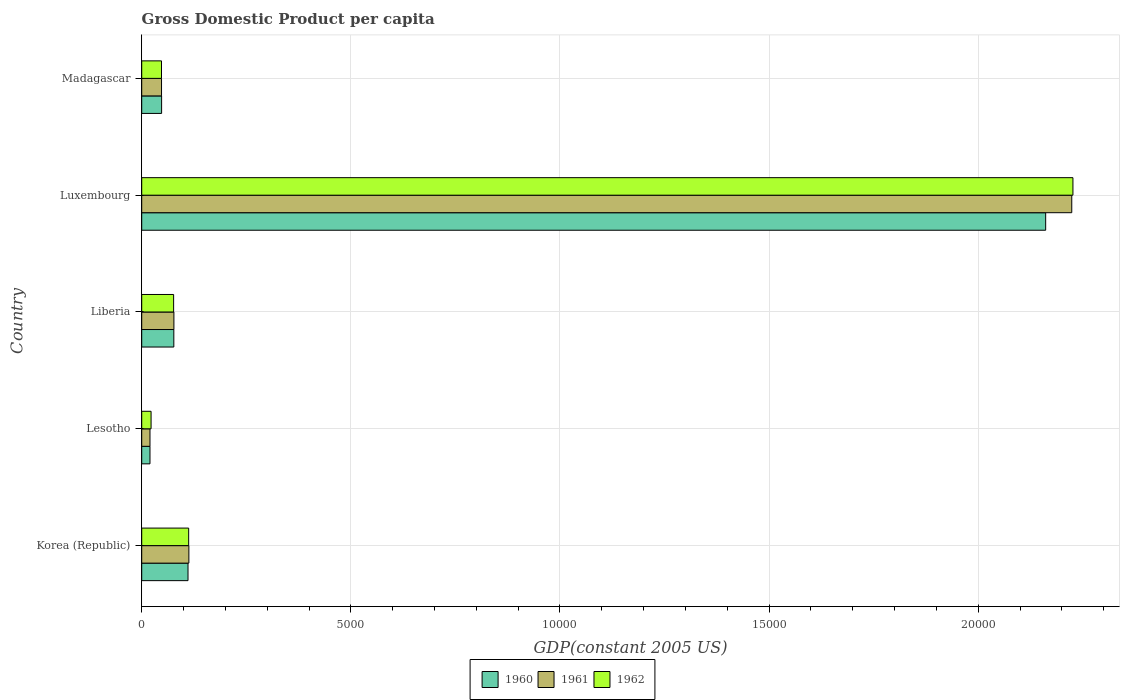How many groups of bars are there?
Give a very brief answer. 5. Are the number of bars on each tick of the Y-axis equal?
Your response must be concise. Yes. What is the label of the 3rd group of bars from the top?
Your answer should be compact. Liberia. What is the GDP per capita in 1962 in Luxembourg?
Provide a succinct answer. 2.23e+04. Across all countries, what is the maximum GDP per capita in 1960?
Make the answer very short. 2.16e+04. Across all countries, what is the minimum GDP per capita in 1961?
Provide a succinct answer. 197.61. In which country was the GDP per capita in 1961 maximum?
Keep it short and to the point. Luxembourg. In which country was the GDP per capita in 1960 minimum?
Your answer should be very brief. Lesotho. What is the total GDP per capita in 1962 in the graph?
Provide a short and direct response. 2.48e+04. What is the difference between the GDP per capita in 1960 in Korea (Republic) and that in Madagascar?
Your response must be concise. 631.26. What is the difference between the GDP per capita in 1960 in Luxembourg and the GDP per capita in 1962 in Madagascar?
Make the answer very short. 2.11e+04. What is the average GDP per capita in 1960 per country?
Provide a short and direct response. 4832.16. What is the difference between the GDP per capita in 1960 and GDP per capita in 1961 in Luxembourg?
Offer a very short reply. -624.17. What is the ratio of the GDP per capita in 1960 in Lesotho to that in Luxembourg?
Your response must be concise. 0.01. Is the GDP per capita in 1962 in Korea (Republic) less than that in Madagascar?
Provide a succinct answer. No. Is the difference between the GDP per capita in 1960 in Korea (Republic) and Lesotho greater than the difference between the GDP per capita in 1961 in Korea (Republic) and Lesotho?
Give a very brief answer. No. What is the difference between the highest and the second highest GDP per capita in 1960?
Give a very brief answer. 2.05e+04. What is the difference between the highest and the lowest GDP per capita in 1960?
Provide a succinct answer. 2.14e+04. What does the 2nd bar from the bottom in Korea (Republic) represents?
Give a very brief answer. 1961. Does the graph contain grids?
Provide a short and direct response. Yes. What is the title of the graph?
Offer a terse response. Gross Domestic Product per capita. Does "2013" appear as one of the legend labels in the graph?
Offer a terse response. No. What is the label or title of the X-axis?
Provide a succinct answer. GDP(constant 2005 US). What is the label or title of the Y-axis?
Your response must be concise. Country. What is the GDP(constant 2005 US) of 1960 in Korea (Republic)?
Your answer should be compact. 1106.76. What is the GDP(constant 2005 US) in 1961 in Korea (Republic)?
Your response must be concise. 1127.44. What is the GDP(constant 2005 US) of 1962 in Korea (Republic)?
Provide a succinct answer. 1122.59. What is the GDP(constant 2005 US) in 1960 in Lesotho?
Make the answer very short. 197.38. What is the GDP(constant 2005 US) in 1961 in Lesotho?
Provide a succinct answer. 197.61. What is the GDP(constant 2005 US) in 1962 in Lesotho?
Keep it short and to the point. 223.86. What is the GDP(constant 2005 US) of 1960 in Liberia?
Keep it short and to the point. 767.6. What is the GDP(constant 2005 US) of 1961 in Liberia?
Offer a terse response. 769.44. What is the GDP(constant 2005 US) of 1962 in Liberia?
Give a very brief answer. 762.88. What is the GDP(constant 2005 US) of 1960 in Luxembourg?
Your answer should be very brief. 2.16e+04. What is the GDP(constant 2005 US) of 1961 in Luxembourg?
Make the answer very short. 2.22e+04. What is the GDP(constant 2005 US) in 1962 in Luxembourg?
Give a very brief answer. 2.23e+04. What is the GDP(constant 2005 US) in 1960 in Madagascar?
Offer a very short reply. 475.5. What is the GDP(constant 2005 US) in 1961 in Madagascar?
Keep it short and to the point. 473.7. What is the GDP(constant 2005 US) in 1962 in Madagascar?
Ensure brevity in your answer.  472.78. Across all countries, what is the maximum GDP(constant 2005 US) in 1960?
Offer a terse response. 2.16e+04. Across all countries, what is the maximum GDP(constant 2005 US) of 1961?
Give a very brief answer. 2.22e+04. Across all countries, what is the maximum GDP(constant 2005 US) of 1962?
Your response must be concise. 2.23e+04. Across all countries, what is the minimum GDP(constant 2005 US) of 1960?
Offer a very short reply. 197.38. Across all countries, what is the minimum GDP(constant 2005 US) of 1961?
Keep it short and to the point. 197.61. Across all countries, what is the minimum GDP(constant 2005 US) of 1962?
Provide a short and direct response. 223.86. What is the total GDP(constant 2005 US) of 1960 in the graph?
Keep it short and to the point. 2.42e+04. What is the total GDP(constant 2005 US) in 1961 in the graph?
Keep it short and to the point. 2.48e+04. What is the total GDP(constant 2005 US) of 1962 in the graph?
Ensure brevity in your answer.  2.48e+04. What is the difference between the GDP(constant 2005 US) in 1960 in Korea (Republic) and that in Lesotho?
Provide a succinct answer. 909.38. What is the difference between the GDP(constant 2005 US) of 1961 in Korea (Republic) and that in Lesotho?
Provide a short and direct response. 929.82. What is the difference between the GDP(constant 2005 US) in 1962 in Korea (Republic) and that in Lesotho?
Offer a very short reply. 898.73. What is the difference between the GDP(constant 2005 US) of 1960 in Korea (Republic) and that in Liberia?
Offer a very short reply. 339.16. What is the difference between the GDP(constant 2005 US) in 1961 in Korea (Republic) and that in Liberia?
Provide a succinct answer. 357.99. What is the difference between the GDP(constant 2005 US) of 1962 in Korea (Republic) and that in Liberia?
Make the answer very short. 359.71. What is the difference between the GDP(constant 2005 US) of 1960 in Korea (Republic) and that in Luxembourg?
Keep it short and to the point. -2.05e+04. What is the difference between the GDP(constant 2005 US) in 1961 in Korea (Republic) and that in Luxembourg?
Keep it short and to the point. -2.11e+04. What is the difference between the GDP(constant 2005 US) of 1962 in Korea (Republic) and that in Luxembourg?
Make the answer very short. -2.11e+04. What is the difference between the GDP(constant 2005 US) of 1960 in Korea (Republic) and that in Madagascar?
Your response must be concise. 631.26. What is the difference between the GDP(constant 2005 US) in 1961 in Korea (Republic) and that in Madagascar?
Ensure brevity in your answer.  653.74. What is the difference between the GDP(constant 2005 US) in 1962 in Korea (Republic) and that in Madagascar?
Provide a short and direct response. 649.82. What is the difference between the GDP(constant 2005 US) in 1960 in Lesotho and that in Liberia?
Offer a very short reply. -570.22. What is the difference between the GDP(constant 2005 US) of 1961 in Lesotho and that in Liberia?
Offer a very short reply. -571.83. What is the difference between the GDP(constant 2005 US) in 1962 in Lesotho and that in Liberia?
Offer a terse response. -539.02. What is the difference between the GDP(constant 2005 US) of 1960 in Lesotho and that in Luxembourg?
Offer a terse response. -2.14e+04. What is the difference between the GDP(constant 2005 US) of 1961 in Lesotho and that in Luxembourg?
Provide a succinct answer. -2.20e+04. What is the difference between the GDP(constant 2005 US) of 1962 in Lesotho and that in Luxembourg?
Ensure brevity in your answer.  -2.20e+04. What is the difference between the GDP(constant 2005 US) of 1960 in Lesotho and that in Madagascar?
Your answer should be compact. -278.12. What is the difference between the GDP(constant 2005 US) in 1961 in Lesotho and that in Madagascar?
Your answer should be very brief. -276.09. What is the difference between the GDP(constant 2005 US) of 1962 in Lesotho and that in Madagascar?
Make the answer very short. -248.91. What is the difference between the GDP(constant 2005 US) of 1960 in Liberia and that in Luxembourg?
Make the answer very short. -2.08e+04. What is the difference between the GDP(constant 2005 US) in 1961 in Liberia and that in Luxembourg?
Ensure brevity in your answer.  -2.15e+04. What is the difference between the GDP(constant 2005 US) of 1962 in Liberia and that in Luxembourg?
Give a very brief answer. -2.15e+04. What is the difference between the GDP(constant 2005 US) in 1960 in Liberia and that in Madagascar?
Your response must be concise. 292.1. What is the difference between the GDP(constant 2005 US) of 1961 in Liberia and that in Madagascar?
Your response must be concise. 295.74. What is the difference between the GDP(constant 2005 US) of 1962 in Liberia and that in Madagascar?
Your answer should be very brief. 290.11. What is the difference between the GDP(constant 2005 US) in 1960 in Luxembourg and that in Madagascar?
Ensure brevity in your answer.  2.11e+04. What is the difference between the GDP(constant 2005 US) of 1961 in Luxembourg and that in Madagascar?
Your answer should be compact. 2.18e+04. What is the difference between the GDP(constant 2005 US) of 1962 in Luxembourg and that in Madagascar?
Your answer should be compact. 2.18e+04. What is the difference between the GDP(constant 2005 US) of 1960 in Korea (Republic) and the GDP(constant 2005 US) of 1961 in Lesotho?
Offer a very short reply. 909.15. What is the difference between the GDP(constant 2005 US) in 1960 in Korea (Republic) and the GDP(constant 2005 US) in 1962 in Lesotho?
Ensure brevity in your answer.  882.89. What is the difference between the GDP(constant 2005 US) of 1961 in Korea (Republic) and the GDP(constant 2005 US) of 1962 in Lesotho?
Keep it short and to the point. 903.57. What is the difference between the GDP(constant 2005 US) in 1960 in Korea (Republic) and the GDP(constant 2005 US) in 1961 in Liberia?
Give a very brief answer. 337.32. What is the difference between the GDP(constant 2005 US) of 1960 in Korea (Republic) and the GDP(constant 2005 US) of 1962 in Liberia?
Give a very brief answer. 343.88. What is the difference between the GDP(constant 2005 US) of 1961 in Korea (Republic) and the GDP(constant 2005 US) of 1962 in Liberia?
Provide a succinct answer. 364.55. What is the difference between the GDP(constant 2005 US) of 1960 in Korea (Republic) and the GDP(constant 2005 US) of 1961 in Luxembourg?
Your answer should be very brief. -2.11e+04. What is the difference between the GDP(constant 2005 US) in 1960 in Korea (Republic) and the GDP(constant 2005 US) in 1962 in Luxembourg?
Your answer should be compact. -2.12e+04. What is the difference between the GDP(constant 2005 US) of 1961 in Korea (Republic) and the GDP(constant 2005 US) of 1962 in Luxembourg?
Offer a very short reply. -2.11e+04. What is the difference between the GDP(constant 2005 US) of 1960 in Korea (Republic) and the GDP(constant 2005 US) of 1961 in Madagascar?
Your answer should be very brief. 633.06. What is the difference between the GDP(constant 2005 US) of 1960 in Korea (Republic) and the GDP(constant 2005 US) of 1962 in Madagascar?
Ensure brevity in your answer.  633.98. What is the difference between the GDP(constant 2005 US) of 1961 in Korea (Republic) and the GDP(constant 2005 US) of 1962 in Madagascar?
Ensure brevity in your answer.  654.66. What is the difference between the GDP(constant 2005 US) of 1960 in Lesotho and the GDP(constant 2005 US) of 1961 in Liberia?
Your answer should be very brief. -572.07. What is the difference between the GDP(constant 2005 US) in 1960 in Lesotho and the GDP(constant 2005 US) in 1962 in Liberia?
Provide a short and direct response. -565.51. What is the difference between the GDP(constant 2005 US) of 1961 in Lesotho and the GDP(constant 2005 US) of 1962 in Liberia?
Your answer should be compact. -565.27. What is the difference between the GDP(constant 2005 US) in 1960 in Lesotho and the GDP(constant 2005 US) in 1961 in Luxembourg?
Your answer should be very brief. -2.20e+04. What is the difference between the GDP(constant 2005 US) of 1960 in Lesotho and the GDP(constant 2005 US) of 1962 in Luxembourg?
Offer a terse response. -2.21e+04. What is the difference between the GDP(constant 2005 US) in 1961 in Lesotho and the GDP(constant 2005 US) in 1962 in Luxembourg?
Make the answer very short. -2.21e+04. What is the difference between the GDP(constant 2005 US) in 1960 in Lesotho and the GDP(constant 2005 US) in 1961 in Madagascar?
Your answer should be compact. -276.32. What is the difference between the GDP(constant 2005 US) of 1960 in Lesotho and the GDP(constant 2005 US) of 1962 in Madagascar?
Keep it short and to the point. -275.4. What is the difference between the GDP(constant 2005 US) in 1961 in Lesotho and the GDP(constant 2005 US) in 1962 in Madagascar?
Your answer should be compact. -275.16. What is the difference between the GDP(constant 2005 US) of 1960 in Liberia and the GDP(constant 2005 US) of 1961 in Luxembourg?
Your answer should be compact. -2.15e+04. What is the difference between the GDP(constant 2005 US) in 1960 in Liberia and the GDP(constant 2005 US) in 1962 in Luxembourg?
Give a very brief answer. -2.15e+04. What is the difference between the GDP(constant 2005 US) in 1961 in Liberia and the GDP(constant 2005 US) in 1962 in Luxembourg?
Your response must be concise. -2.15e+04. What is the difference between the GDP(constant 2005 US) in 1960 in Liberia and the GDP(constant 2005 US) in 1961 in Madagascar?
Offer a terse response. 293.9. What is the difference between the GDP(constant 2005 US) in 1960 in Liberia and the GDP(constant 2005 US) in 1962 in Madagascar?
Your answer should be very brief. 294.82. What is the difference between the GDP(constant 2005 US) in 1961 in Liberia and the GDP(constant 2005 US) in 1962 in Madagascar?
Provide a succinct answer. 296.67. What is the difference between the GDP(constant 2005 US) in 1960 in Luxembourg and the GDP(constant 2005 US) in 1961 in Madagascar?
Make the answer very short. 2.11e+04. What is the difference between the GDP(constant 2005 US) in 1960 in Luxembourg and the GDP(constant 2005 US) in 1962 in Madagascar?
Make the answer very short. 2.11e+04. What is the difference between the GDP(constant 2005 US) in 1961 in Luxembourg and the GDP(constant 2005 US) in 1962 in Madagascar?
Make the answer very short. 2.18e+04. What is the average GDP(constant 2005 US) in 1960 per country?
Your response must be concise. 4832.16. What is the average GDP(constant 2005 US) in 1961 per country?
Your response must be concise. 4961.19. What is the average GDP(constant 2005 US) in 1962 per country?
Offer a terse response. 4969.52. What is the difference between the GDP(constant 2005 US) in 1960 and GDP(constant 2005 US) in 1961 in Korea (Republic)?
Keep it short and to the point. -20.68. What is the difference between the GDP(constant 2005 US) of 1960 and GDP(constant 2005 US) of 1962 in Korea (Republic)?
Provide a short and direct response. -15.83. What is the difference between the GDP(constant 2005 US) of 1961 and GDP(constant 2005 US) of 1962 in Korea (Republic)?
Offer a terse response. 4.85. What is the difference between the GDP(constant 2005 US) in 1960 and GDP(constant 2005 US) in 1961 in Lesotho?
Offer a very short reply. -0.24. What is the difference between the GDP(constant 2005 US) in 1960 and GDP(constant 2005 US) in 1962 in Lesotho?
Offer a very short reply. -26.49. What is the difference between the GDP(constant 2005 US) in 1961 and GDP(constant 2005 US) in 1962 in Lesotho?
Ensure brevity in your answer.  -26.25. What is the difference between the GDP(constant 2005 US) of 1960 and GDP(constant 2005 US) of 1961 in Liberia?
Ensure brevity in your answer.  -1.85. What is the difference between the GDP(constant 2005 US) of 1960 and GDP(constant 2005 US) of 1962 in Liberia?
Provide a succinct answer. 4.71. What is the difference between the GDP(constant 2005 US) of 1961 and GDP(constant 2005 US) of 1962 in Liberia?
Ensure brevity in your answer.  6.56. What is the difference between the GDP(constant 2005 US) of 1960 and GDP(constant 2005 US) of 1961 in Luxembourg?
Ensure brevity in your answer.  -624.17. What is the difference between the GDP(constant 2005 US) of 1960 and GDP(constant 2005 US) of 1962 in Luxembourg?
Offer a terse response. -651.89. What is the difference between the GDP(constant 2005 US) in 1961 and GDP(constant 2005 US) in 1962 in Luxembourg?
Your answer should be very brief. -27.73. What is the difference between the GDP(constant 2005 US) in 1960 and GDP(constant 2005 US) in 1961 in Madagascar?
Offer a terse response. 1.8. What is the difference between the GDP(constant 2005 US) of 1960 and GDP(constant 2005 US) of 1962 in Madagascar?
Keep it short and to the point. 2.72. What is the difference between the GDP(constant 2005 US) in 1961 and GDP(constant 2005 US) in 1962 in Madagascar?
Your answer should be compact. 0.92. What is the ratio of the GDP(constant 2005 US) in 1960 in Korea (Republic) to that in Lesotho?
Provide a succinct answer. 5.61. What is the ratio of the GDP(constant 2005 US) in 1961 in Korea (Republic) to that in Lesotho?
Provide a succinct answer. 5.71. What is the ratio of the GDP(constant 2005 US) of 1962 in Korea (Republic) to that in Lesotho?
Provide a succinct answer. 5.01. What is the ratio of the GDP(constant 2005 US) of 1960 in Korea (Republic) to that in Liberia?
Ensure brevity in your answer.  1.44. What is the ratio of the GDP(constant 2005 US) of 1961 in Korea (Republic) to that in Liberia?
Your answer should be compact. 1.47. What is the ratio of the GDP(constant 2005 US) in 1962 in Korea (Republic) to that in Liberia?
Provide a short and direct response. 1.47. What is the ratio of the GDP(constant 2005 US) of 1960 in Korea (Republic) to that in Luxembourg?
Give a very brief answer. 0.05. What is the ratio of the GDP(constant 2005 US) in 1961 in Korea (Republic) to that in Luxembourg?
Your response must be concise. 0.05. What is the ratio of the GDP(constant 2005 US) of 1962 in Korea (Republic) to that in Luxembourg?
Your answer should be compact. 0.05. What is the ratio of the GDP(constant 2005 US) of 1960 in Korea (Republic) to that in Madagascar?
Your answer should be compact. 2.33. What is the ratio of the GDP(constant 2005 US) of 1961 in Korea (Republic) to that in Madagascar?
Make the answer very short. 2.38. What is the ratio of the GDP(constant 2005 US) in 1962 in Korea (Republic) to that in Madagascar?
Give a very brief answer. 2.37. What is the ratio of the GDP(constant 2005 US) of 1960 in Lesotho to that in Liberia?
Your response must be concise. 0.26. What is the ratio of the GDP(constant 2005 US) in 1961 in Lesotho to that in Liberia?
Offer a terse response. 0.26. What is the ratio of the GDP(constant 2005 US) in 1962 in Lesotho to that in Liberia?
Your answer should be compact. 0.29. What is the ratio of the GDP(constant 2005 US) in 1960 in Lesotho to that in Luxembourg?
Your answer should be very brief. 0.01. What is the ratio of the GDP(constant 2005 US) of 1961 in Lesotho to that in Luxembourg?
Offer a terse response. 0.01. What is the ratio of the GDP(constant 2005 US) of 1962 in Lesotho to that in Luxembourg?
Make the answer very short. 0.01. What is the ratio of the GDP(constant 2005 US) in 1960 in Lesotho to that in Madagascar?
Provide a succinct answer. 0.42. What is the ratio of the GDP(constant 2005 US) in 1961 in Lesotho to that in Madagascar?
Provide a short and direct response. 0.42. What is the ratio of the GDP(constant 2005 US) in 1962 in Lesotho to that in Madagascar?
Ensure brevity in your answer.  0.47. What is the ratio of the GDP(constant 2005 US) of 1960 in Liberia to that in Luxembourg?
Ensure brevity in your answer.  0.04. What is the ratio of the GDP(constant 2005 US) in 1961 in Liberia to that in Luxembourg?
Keep it short and to the point. 0.03. What is the ratio of the GDP(constant 2005 US) of 1962 in Liberia to that in Luxembourg?
Your answer should be compact. 0.03. What is the ratio of the GDP(constant 2005 US) in 1960 in Liberia to that in Madagascar?
Make the answer very short. 1.61. What is the ratio of the GDP(constant 2005 US) in 1961 in Liberia to that in Madagascar?
Offer a very short reply. 1.62. What is the ratio of the GDP(constant 2005 US) of 1962 in Liberia to that in Madagascar?
Your response must be concise. 1.61. What is the ratio of the GDP(constant 2005 US) of 1960 in Luxembourg to that in Madagascar?
Your response must be concise. 45.45. What is the ratio of the GDP(constant 2005 US) of 1961 in Luxembourg to that in Madagascar?
Make the answer very short. 46.95. What is the ratio of the GDP(constant 2005 US) of 1962 in Luxembourg to that in Madagascar?
Your answer should be compact. 47.1. What is the difference between the highest and the second highest GDP(constant 2005 US) of 1960?
Give a very brief answer. 2.05e+04. What is the difference between the highest and the second highest GDP(constant 2005 US) in 1961?
Give a very brief answer. 2.11e+04. What is the difference between the highest and the second highest GDP(constant 2005 US) in 1962?
Keep it short and to the point. 2.11e+04. What is the difference between the highest and the lowest GDP(constant 2005 US) in 1960?
Ensure brevity in your answer.  2.14e+04. What is the difference between the highest and the lowest GDP(constant 2005 US) of 1961?
Make the answer very short. 2.20e+04. What is the difference between the highest and the lowest GDP(constant 2005 US) in 1962?
Ensure brevity in your answer.  2.20e+04. 